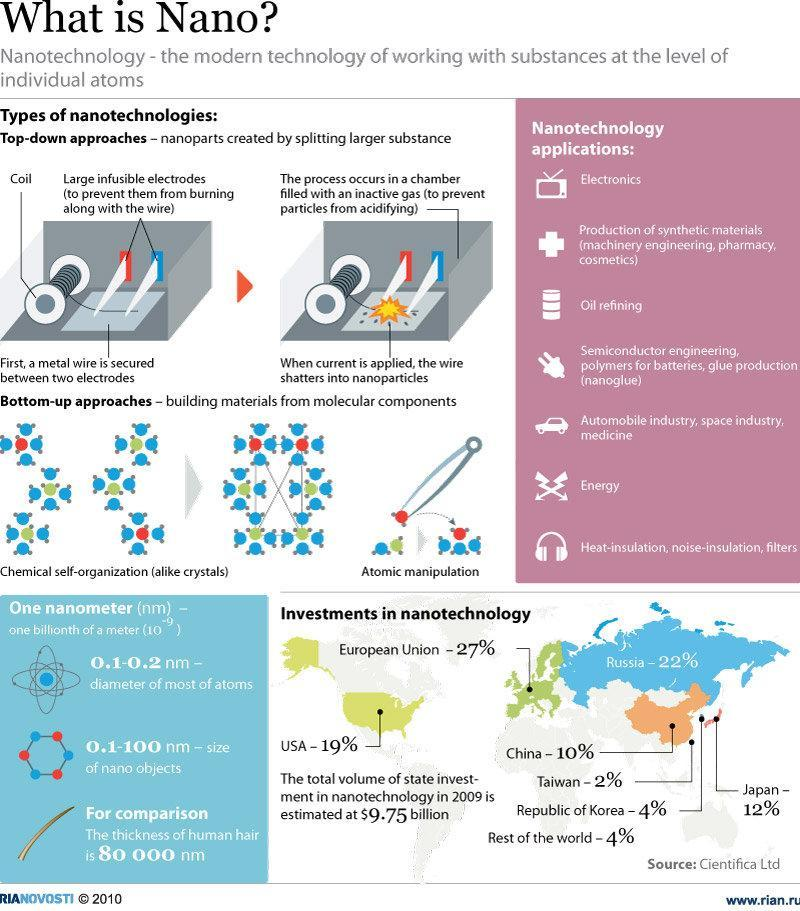what nanotechnology application is shown by an ear phone icon
Answer the question with a short phrase. heat-insulation, noise-insulation, filters Other than top-down approaches, what other type of nanotechnology is there bottom-up approaches how much more in % has Russia invested when compared to USA 3 The investment by Republic of Korea is equal to what rest of the world what nanotechnology application is shown by a television icon electronics 